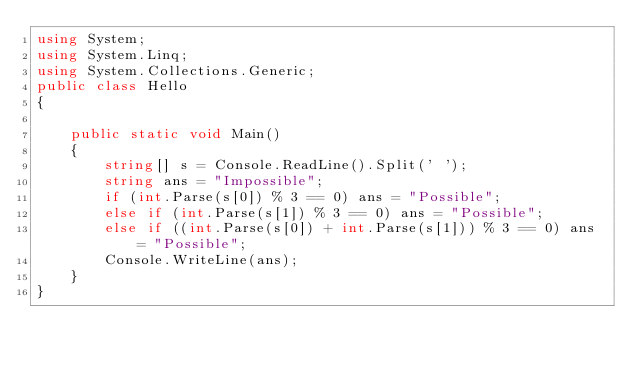Convert code to text. <code><loc_0><loc_0><loc_500><loc_500><_C#_>using System;
using System.Linq;
using System.Collections.Generic;
public class Hello
{

    public static void Main()
    {
        string[] s = Console.ReadLine().Split(' ');
        string ans = "Impossible";
        if (int.Parse(s[0]) % 3 == 0) ans = "Possible";
        else if (int.Parse(s[1]) % 3 == 0) ans = "Possible";
        else if ((int.Parse(s[0]) + int.Parse(s[1])) % 3 == 0) ans = "Possible";
        Console.WriteLine(ans);
    }
}</code> 